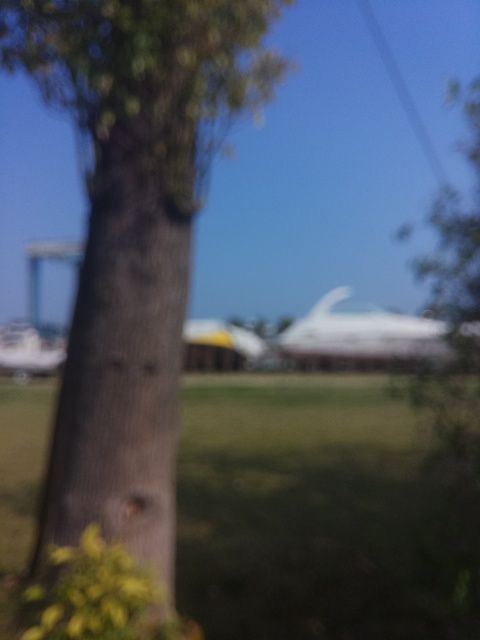What can we infer about the weather in this scene? The lighting suggests that the weather could be partly cloudy or hazy, as the light does not seem harsh, which might indicate that the sun is obscured by cloud cover. 